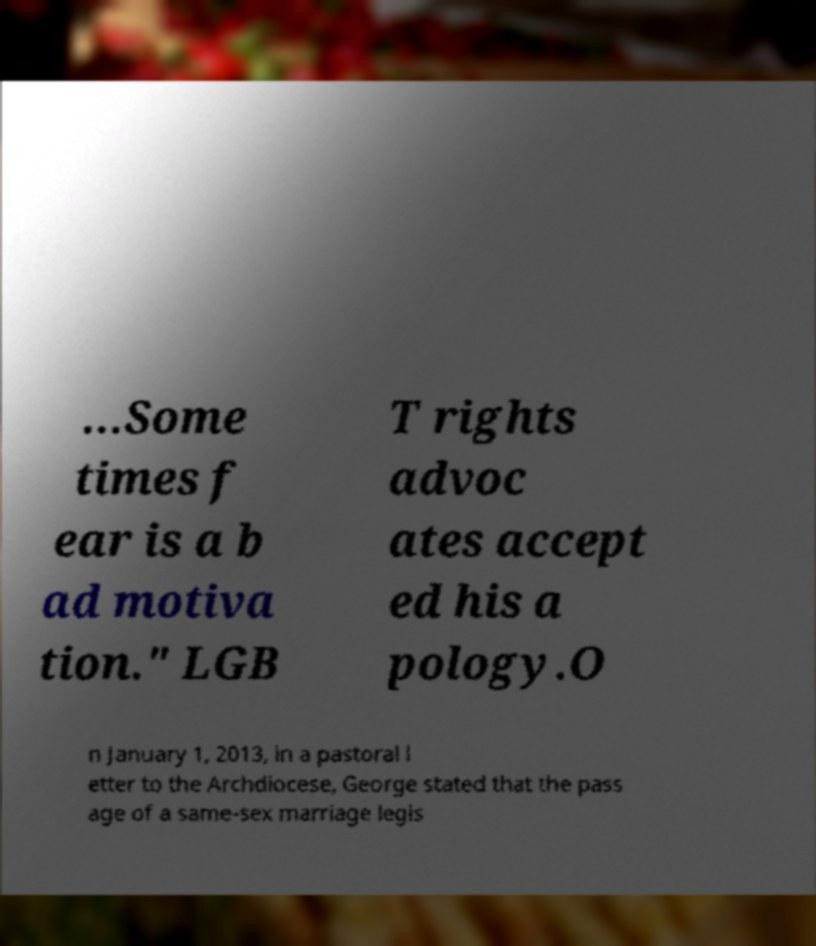What messages or text are displayed in this image? I need them in a readable, typed format. ...Some times f ear is a b ad motiva tion." LGB T rights advoc ates accept ed his a pology.O n January 1, 2013, in a pastoral l etter to the Archdiocese, George stated that the pass age of a same-sex marriage legis 